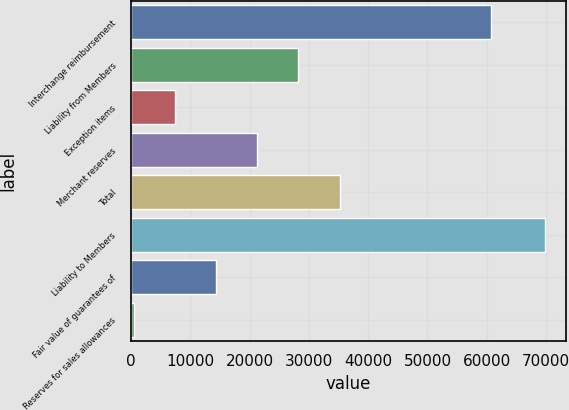Convert chart. <chart><loc_0><loc_0><loc_500><loc_500><bar_chart><fcel>Interchange reimbursement<fcel>Liability from Members<fcel>Exception items<fcel>Merchant reserves<fcel>Total<fcel>Liability to Members<fcel>Fair value of guarantees of<fcel>Reserves for sales allowances<nl><fcel>60734<fcel>28222.6<fcel>7422.4<fcel>21289.2<fcel>35156<fcel>69823<fcel>14355.8<fcel>489<nl></chart> 